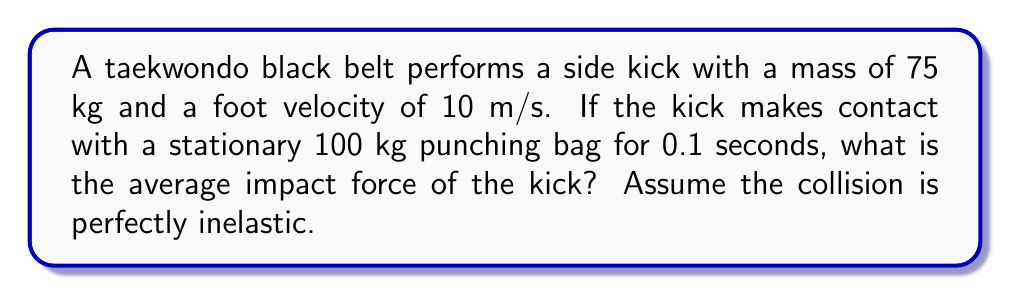Teach me how to tackle this problem. Let's approach this step-by-step using conservation of momentum principles:

1) First, we need to calculate the momentum of the kicker's foot just before impact:
   $p_i = m_1v_1 = 75 \text{ kg} \cdot 10 \text{ m/s} = 750 \text{ kg}\cdot\text{m/s}$

2) After the collision, the kicker's foot and the punching bag move together (perfectly inelastic collision). We can find the final velocity using conservation of momentum:
   $p_i = p_f$
   $m_1v_1 = (m_1 + m_2)v_f$
   $750 = (75 + 100)v_f$
   $v_f = \frac{750}{175} = 4.29 \text{ m/s}$

3) Now we can calculate the change in momentum:
   $\Delta p = p_f - p_i = (m_1 + m_2)v_f - m_1v_1$
   $\Delta p = 175 \cdot 4.29 - 750 = 0 - 750 = -750 \text{ kg}\cdot\text{m/s}$

4) The impact force can be calculated using the impulse-momentum theorem:
   $F \cdot \Delta t = \Delta p$
   $F = \frac{\Delta p}{\Delta t} = \frac{-750 \text{ kg}\cdot\text{m/s}}{0.1 \text{ s}}$

5) Taking the absolute value for the magnitude of the force:
   $F = |-7500| = 7500 \text{ N}$

Therefore, the average impact force of the kick is 7500 N.
Answer: 7500 N 